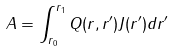Convert formula to latex. <formula><loc_0><loc_0><loc_500><loc_500>A = \int _ { r _ { 0 } } ^ { r _ { 1 } } Q ( r , r ^ { \prime } ) J ( r ^ { \prime } ) d r ^ { \prime }</formula> 